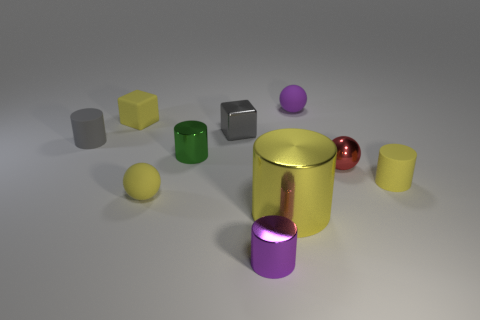What number of purple objects are either small shiny cylinders or matte balls? There are two purple objects that match the criteria: one small shiny cylinder and one matte ball. 